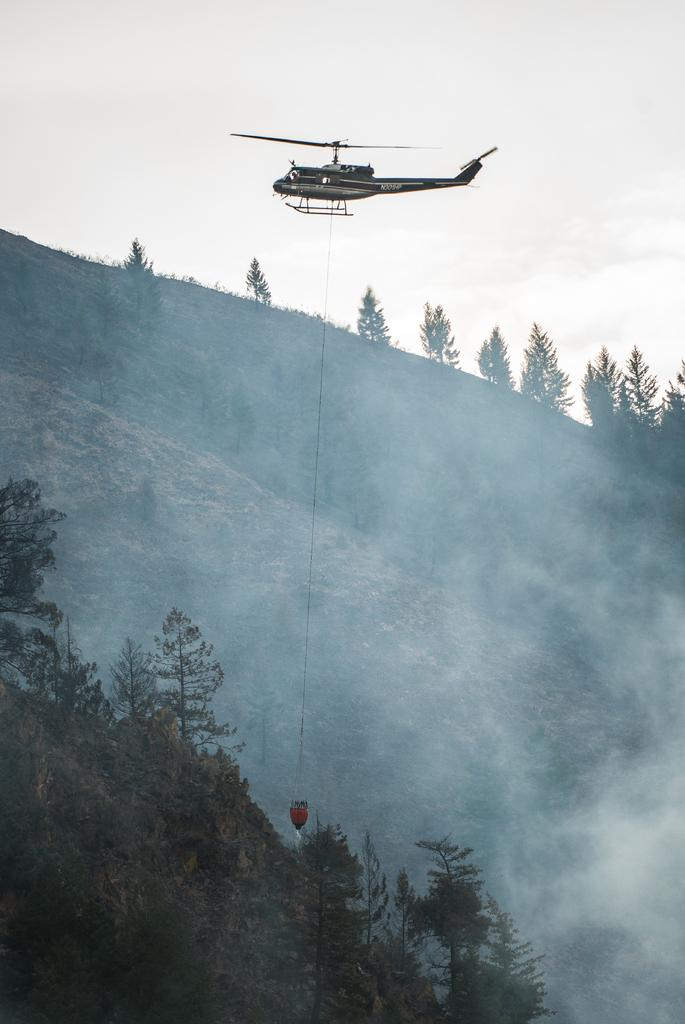What is the main geographical feature in the image? There is a mountain in the image. What type of vegetation can be seen in the image? There are trees in the image. What mode of transportation is present in the image? There is a helicopter flying in the image. What is visible at the top of the image? The sky is visible at the top of the image. Where is the jar of nails located in the image? There is no jar of nails present in the image. What part of the brain can be seen in the image? There is no brain present in the image. 